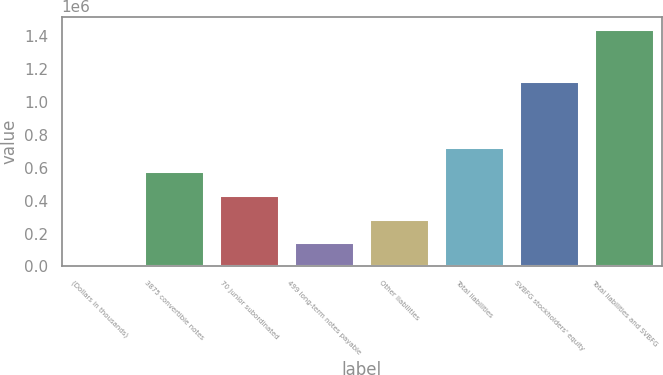Convert chart to OTSL. <chart><loc_0><loc_0><loc_500><loc_500><bar_chart><fcel>(Dollars in thousands)<fcel>3875 convertible notes<fcel>70 junior subordinated<fcel>499 long-term notes payable<fcel>Other liabilities<fcel>Total liabilities<fcel>SVBFG stockholders' equity<fcel>Total liabilities and SVBFG<nl><fcel>2009<fcel>579850<fcel>435390<fcel>146469<fcel>290929<fcel>724310<fcel>1.12834e+06<fcel>1.44661e+06<nl></chart> 